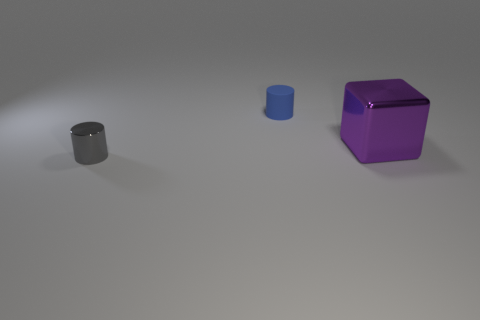Is there anything else that has the same material as the small blue object?
Provide a succinct answer. No. There is a thing that is both in front of the blue cylinder and on the right side of the small gray shiny cylinder; what size is it?
Your response must be concise. Large. Does the cylinder that is in front of the large purple cube have the same material as the purple object?
Your answer should be compact. Yes. Is there any other thing that is the same size as the purple thing?
Provide a succinct answer. No. Is the number of large purple metallic cubes behind the small matte cylinder less than the number of purple blocks that are to the right of the gray cylinder?
Offer a very short reply. Yes. Is there anything else that has the same shape as the large metallic object?
Provide a succinct answer. No. There is a metallic thing that is on the right side of the small thing behind the tiny gray metal cylinder; what number of blue things are to the left of it?
Give a very brief answer. 1. What number of tiny blue rubber objects are in front of the gray shiny cylinder?
Ensure brevity in your answer.  0. What number of gray cylinders have the same material as the purple cube?
Offer a terse response. 1. What color is the tiny object that is the same material as the large purple cube?
Provide a succinct answer. Gray. 